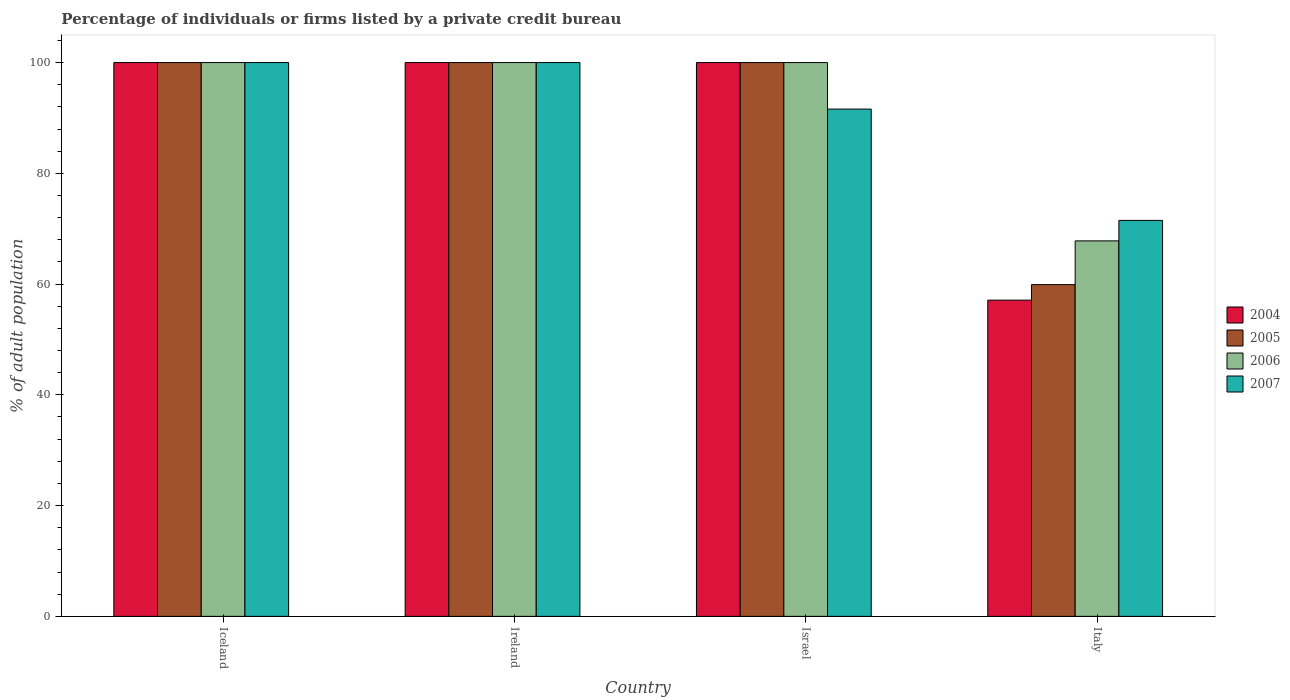How many different coloured bars are there?
Your answer should be compact. 4. How many groups of bars are there?
Your response must be concise. 4. Are the number of bars per tick equal to the number of legend labels?
Your response must be concise. Yes. Are the number of bars on each tick of the X-axis equal?
Your answer should be very brief. Yes. How many bars are there on the 2nd tick from the right?
Provide a succinct answer. 4. What is the label of the 1st group of bars from the left?
Provide a short and direct response. Iceland. What is the percentage of population listed by a private credit bureau in 2005 in Italy?
Your response must be concise. 59.9. Across all countries, what is the minimum percentage of population listed by a private credit bureau in 2004?
Make the answer very short. 57.1. What is the total percentage of population listed by a private credit bureau in 2007 in the graph?
Ensure brevity in your answer.  363.1. What is the difference between the percentage of population listed by a private credit bureau in 2007 in Ireland and the percentage of population listed by a private credit bureau in 2005 in Italy?
Ensure brevity in your answer.  40.1. What is the average percentage of population listed by a private credit bureau in 2004 per country?
Make the answer very short. 89.28. What is the difference between the percentage of population listed by a private credit bureau of/in 2007 and percentage of population listed by a private credit bureau of/in 2006 in Israel?
Ensure brevity in your answer.  -8.4. In how many countries, is the percentage of population listed by a private credit bureau in 2007 greater than 8 %?
Keep it short and to the point. 4. Is the percentage of population listed by a private credit bureau in 2005 in Iceland less than that in Ireland?
Offer a terse response. No. Is the difference between the percentage of population listed by a private credit bureau in 2007 in Ireland and Israel greater than the difference between the percentage of population listed by a private credit bureau in 2006 in Ireland and Israel?
Make the answer very short. Yes. What is the difference between the highest and the second highest percentage of population listed by a private credit bureau in 2007?
Provide a succinct answer. -8.4. What is the difference between the highest and the lowest percentage of population listed by a private credit bureau in 2007?
Keep it short and to the point. 28.5. In how many countries, is the percentage of population listed by a private credit bureau in 2007 greater than the average percentage of population listed by a private credit bureau in 2007 taken over all countries?
Your answer should be very brief. 3. Is the sum of the percentage of population listed by a private credit bureau in 2006 in Iceland and Ireland greater than the maximum percentage of population listed by a private credit bureau in 2007 across all countries?
Your answer should be compact. Yes. What does the 3rd bar from the right in Iceland represents?
Provide a succinct answer. 2005. How many bars are there?
Keep it short and to the point. 16. How many countries are there in the graph?
Your answer should be very brief. 4. Are the values on the major ticks of Y-axis written in scientific E-notation?
Make the answer very short. No. How are the legend labels stacked?
Make the answer very short. Vertical. What is the title of the graph?
Your answer should be very brief. Percentage of individuals or firms listed by a private credit bureau. Does "1990" appear as one of the legend labels in the graph?
Make the answer very short. No. What is the label or title of the X-axis?
Give a very brief answer. Country. What is the label or title of the Y-axis?
Give a very brief answer. % of adult population. What is the % of adult population in 2005 in Iceland?
Keep it short and to the point. 100. What is the % of adult population in 2006 in Iceland?
Provide a succinct answer. 100. What is the % of adult population in 2005 in Ireland?
Provide a succinct answer. 100. What is the % of adult population in 2007 in Ireland?
Ensure brevity in your answer.  100. What is the % of adult population of 2005 in Israel?
Your answer should be very brief. 100. What is the % of adult population in 2006 in Israel?
Make the answer very short. 100. What is the % of adult population in 2007 in Israel?
Ensure brevity in your answer.  91.6. What is the % of adult population of 2004 in Italy?
Keep it short and to the point. 57.1. What is the % of adult population of 2005 in Italy?
Your answer should be very brief. 59.9. What is the % of adult population in 2006 in Italy?
Offer a terse response. 67.8. What is the % of adult population in 2007 in Italy?
Your response must be concise. 71.5. Across all countries, what is the maximum % of adult population of 2004?
Provide a succinct answer. 100. Across all countries, what is the maximum % of adult population in 2005?
Ensure brevity in your answer.  100. Across all countries, what is the maximum % of adult population in 2006?
Give a very brief answer. 100. Across all countries, what is the maximum % of adult population of 2007?
Give a very brief answer. 100. Across all countries, what is the minimum % of adult population in 2004?
Offer a very short reply. 57.1. Across all countries, what is the minimum % of adult population of 2005?
Offer a very short reply. 59.9. Across all countries, what is the minimum % of adult population in 2006?
Your answer should be compact. 67.8. Across all countries, what is the minimum % of adult population in 2007?
Provide a short and direct response. 71.5. What is the total % of adult population in 2004 in the graph?
Offer a very short reply. 357.1. What is the total % of adult population in 2005 in the graph?
Give a very brief answer. 359.9. What is the total % of adult population of 2006 in the graph?
Your answer should be very brief. 367.8. What is the total % of adult population in 2007 in the graph?
Keep it short and to the point. 363.1. What is the difference between the % of adult population of 2004 in Iceland and that in Ireland?
Your answer should be compact. 0. What is the difference between the % of adult population in 2005 in Iceland and that in Ireland?
Keep it short and to the point. 0. What is the difference between the % of adult population in 2004 in Iceland and that in Israel?
Offer a very short reply. 0. What is the difference between the % of adult population in 2006 in Iceland and that in Israel?
Your answer should be compact. 0. What is the difference between the % of adult population in 2004 in Iceland and that in Italy?
Your answer should be very brief. 42.9. What is the difference between the % of adult population in 2005 in Iceland and that in Italy?
Make the answer very short. 40.1. What is the difference between the % of adult population in 2006 in Iceland and that in Italy?
Provide a succinct answer. 32.2. What is the difference between the % of adult population in 2004 in Ireland and that in Israel?
Provide a succinct answer. 0. What is the difference between the % of adult population of 2006 in Ireland and that in Israel?
Your answer should be very brief. 0. What is the difference between the % of adult population in 2007 in Ireland and that in Israel?
Keep it short and to the point. 8.4. What is the difference between the % of adult population of 2004 in Ireland and that in Italy?
Offer a very short reply. 42.9. What is the difference between the % of adult population in 2005 in Ireland and that in Italy?
Provide a short and direct response. 40.1. What is the difference between the % of adult population in 2006 in Ireland and that in Italy?
Offer a very short reply. 32.2. What is the difference between the % of adult population in 2007 in Ireland and that in Italy?
Offer a very short reply. 28.5. What is the difference between the % of adult population in 2004 in Israel and that in Italy?
Provide a succinct answer. 42.9. What is the difference between the % of adult population of 2005 in Israel and that in Italy?
Keep it short and to the point. 40.1. What is the difference between the % of adult population in 2006 in Israel and that in Italy?
Offer a very short reply. 32.2. What is the difference between the % of adult population of 2007 in Israel and that in Italy?
Offer a terse response. 20.1. What is the difference between the % of adult population in 2005 in Iceland and the % of adult population in 2006 in Ireland?
Your answer should be very brief. 0. What is the difference between the % of adult population in 2005 in Iceland and the % of adult population in 2007 in Ireland?
Your answer should be very brief. 0. What is the difference between the % of adult population in 2006 in Iceland and the % of adult population in 2007 in Ireland?
Make the answer very short. 0. What is the difference between the % of adult population in 2004 in Iceland and the % of adult population in 2005 in Israel?
Offer a very short reply. 0. What is the difference between the % of adult population in 2004 in Iceland and the % of adult population in 2006 in Israel?
Offer a very short reply. 0. What is the difference between the % of adult population in 2005 in Iceland and the % of adult population in 2006 in Israel?
Give a very brief answer. 0. What is the difference between the % of adult population of 2006 in Iceland and the % of adult population of 2007 in Israel?
Provide a succinct answer. 8.4. What is the difference between the % of adult population of 2004 in Iceland and the % of adult population of 2005 in Italy?
Your response must be concise. 40.1. What is the difference between the % of adult population in 2004 in Iceland and the % of adult population in 2006 in Italy?
Your answer should be compact. 32.2. What is the difference between the % of adult population of 2004 in Iceland and the % of adult population of 2007 in Italy?
Give a very brief answer. 28.5. What is the difference between the % of adult population in 2005 in Iceland and the % of adult population in 2006 in Italy?
Your response must be concise. 32.2. What is the difference between the % of adult population of 2006 in Iceland and the % of adult population of 2007 in Italy?
Keep it short and to the point. 28.5. What is the difference between the % of adult population of 2004 in Ireland and the % of adult population of 2005 in Israel?
Offer a very short reply. 0. What is the difference between the % of adult population in 2004 in Ireland and the % of adult population in 2006 in Israel?
Keep it short and to the point. 0. What is the difference between the % of adult population in 2006 in Ireland and the % of adult population in 2007 in Israel?
Offer a terse response. 8.4. What is the difference between the % of adult population in 2004 in Ireland and the % of adult population in 2005 in Italy?
Provide a succinct answer. 40.1. What is the difference between the % of adult population of 2004 in Ireland and the % of adult population of 2006 in Italy?
Give a very brief answer. 32.2. What is the difference between the % of adult population of 2005 in Ireland and the % of adult population of 2006 in Italy?
Provide a succinct answer. 32.2. What is the difference between the % of adult population in 2006 in Ireland and the % of adult population in 2007 in Italy?
Your answer should be very brief. 28.5. What is the difference between the % of adult population of 2004 in Israel and the % of adult population of 2005 in Italy?
Provide a short and direct response. 40.1. What is the difference between the % of adult population of 2004 in Israel and the % of adult population of 2006 in Italy?
Your response must be concise. 32.2. What is the difference between the % of adult population in 2005 in Israel and the % of adult population in 2006 in Italy?
Your answer should be very brief. 32.2. What is the difference between the % of adult population of 2006 in Israel and the % of adult population of 2007 in Italy?
Provide a short and direct response. 28.5. What is the average % of adult population of 2004 per country?
Make the answer very short. 89.28. What is the average % of adult population in 2005 per country?
Ensure brevity in your answer.  89.97. What is the average % of adult population in 2006 per country?
Provide a short and direct response. 91.95. What is the average % of adult population in 2007 per country?
Your response must be concise. 90.78. What is the difference between the % of adult population in 2004 and % of adult population in 2006 in Iceland?
Offer a very short reply. 0. What is the difference between the % of adult population of 2004 and % of adult population of 2007 in Iceland?
Offer a terse response. 0. What is the difference between the % of adult population of 2005 and % of adult population of 2006 in Iceland?
Offer a very short reply. 0. What is the difference between the % of adult population of 2006 and % of adult population of 2007 in Iceland?
Provide a short and direct response. 0. What is the difference between the % of adult population of 2004 and % of adult population of 2007 in Ireland?
Ensure brevity in your answer.  0. What is the difference between the % of adult population of 2005 and % of adult population of 2006 in Ireland?
Ensure brevity in your answer.  0. What is the difference between the % of adult population in 2004 and % of adult population in 2007 in Israel?
Provide a succinct answer. 8.4. What is the difference between the % of adult population of 2005 and % of adult population of 2007 in Israel?
Make the answer very short. 8.4. What is the difference between the % of adult population in 2004 and % of adult population in 2005 in Italy?
Your response must be concise. -2.8. What is the difference between the % of adult population in 2004 and % of adult population in 2006 in Italy?
Offer a terse response. -10.7. What is the difference between the % of adult population in 2004 and % of adult population in 2007 in Italy?
Keep it short and to the point. -14.4. What is the difference between the % of adult population in 2005 and % of adult population in 2006 in Italy?
Your response must be concise. -7.9. What is the difference between the % of adult population in 2005 and % of adult population in 2007 in Italy?
Give a very brief answer. -11.6. What is the difference between the % of adult population of 2006 and % of adult population of 2007 in Italy?
Offer a terse response. -3.7. What is the ratio of the % of adult population in 2004 in Iceland to that in Ireland?
Your answer should be compact. 1. What is the ratio of the % of adult population of 2005 in Iceland to that in Ireland?
Give a very brief answer. 1. What is the ratio of the % of adult population of 2007 in Iceland to that in Ireland?
Ensure brevity in your answer.  1. What is the ratio of the % of adult population of 2005 in Iceland to that in Israel?
Offer a very short reply. 1. What is the ratio of the % of adult population of 2007 in Iceland to that in Israel?
Provide a short and direct response. 1.09. What is the ratio of the % of adult population in 2004 in Iceland to that in Italy?
Make the answer very short. 1.75. What is the ratio of the % of adult population of 2005 in Iceland to that in Italy?
Offer a terse response. 1.67. What is the ratio of the % of adult population in 2006 in Iceland to that in Italy?
Ensure brevity in your answer.  1.47. What is the ratio of the % of adult population of 2007 in Iceland to that in Italy?
Offer a terse response. 1.4. What is the ratio of the % of adult population of 2004 in Ireland to that in Israel?
Offer a terse response. 1. What is the ratio of the % of adult population in 2006 in Ireland to that in Israel?
Your answer should be very brief. 1. What is the ratio of the % of adult population in 2007 in Ireland to that in Israel?
Ensure brevity in your answer.  1.09. What is the ratio of the % of adult population of 2004 in Ireland to that in Italy?
Your answer should be very brief. 1.75. What is the ratio of the % of adult population in 2005 in Ireland to that in Italy?
Provide a succinct answer. 1.67. What is the ratio of the % of adult population in 2006 in Ireland to that in Italy?
Ensure brevity in your answer.  1.47. What is the ratio of the % of adult population in 2007 in Ireland to that in Italy?
Give a very brief answer. 1.4. What is the ratio of the % of adult population in 2004 in Israel to that in Italy?
Ensure brevity in your answer.  1.75. What is the ratio of the % of adult population of 2005 in Israel to that in Italy?
Ensure brevity in your answer.  1.67. What is the ratio of the % of adult population of 2006 in Israel to that in Italy?
Provide a short and direct response. 1.47. What is the ratio of the % of adult population in 2007 in Israel to that in Italy?
Keep it short and to the point. 1.28. What is the difference between the highest and the second highest % of adult population in 2004?
Your response must be concise. 0. What is the difference between the highest and the second highest % of adult population of 2006?
Your answer should be compact. 0. What is the difference between the highest and the lowest % of adult population of 2004?
Ensure brevity in your answer.  42.9. What is the difference between the highest and the lowest % of adult population in 2005?
Your answer should be very brief. 40.1. What is the difference between the highest and the lowest % of adult population of 2006?
Make the answer very short. 32.2. What is the difference between the highest and the lowest % of adult population of 2007?
Provide a succinct answer. 28.5. 